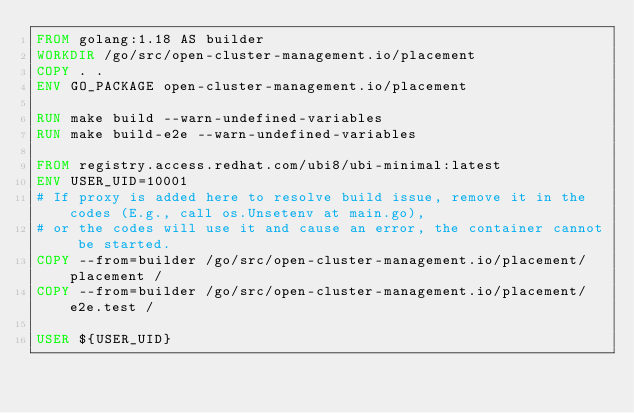Convert code to text. <code><loc_0><loc_0><loc_500><loc_500><_Dockerfile_>FROM golang:1.18 AS builder
WORKDIR /go/src/open-cluster-management.io/placement
COPY . .
ENV GO_PACKAGE open-cluster-management.io/placement

RUN make build --warn-undefined-variables
RUN make build-e2e --warn-undefined-variables

FROM registry.access.redhat.com/ubi8/ubi-minimal:latest
ENV USER_UID=10001
# If proxy is added here to resolve build issue, remove it in the codes (E.g., call os.Unsetenv at main.go),
# or the codes will use it and cause an error, the container cannot be started.
COPY --from=builder /go/src/open-cluster-management.io/placement/placement /
COPY --from=builder /go/src/open-cluster-management.io/placement/e2e.test /

USER ${USER_UID}
</code> 